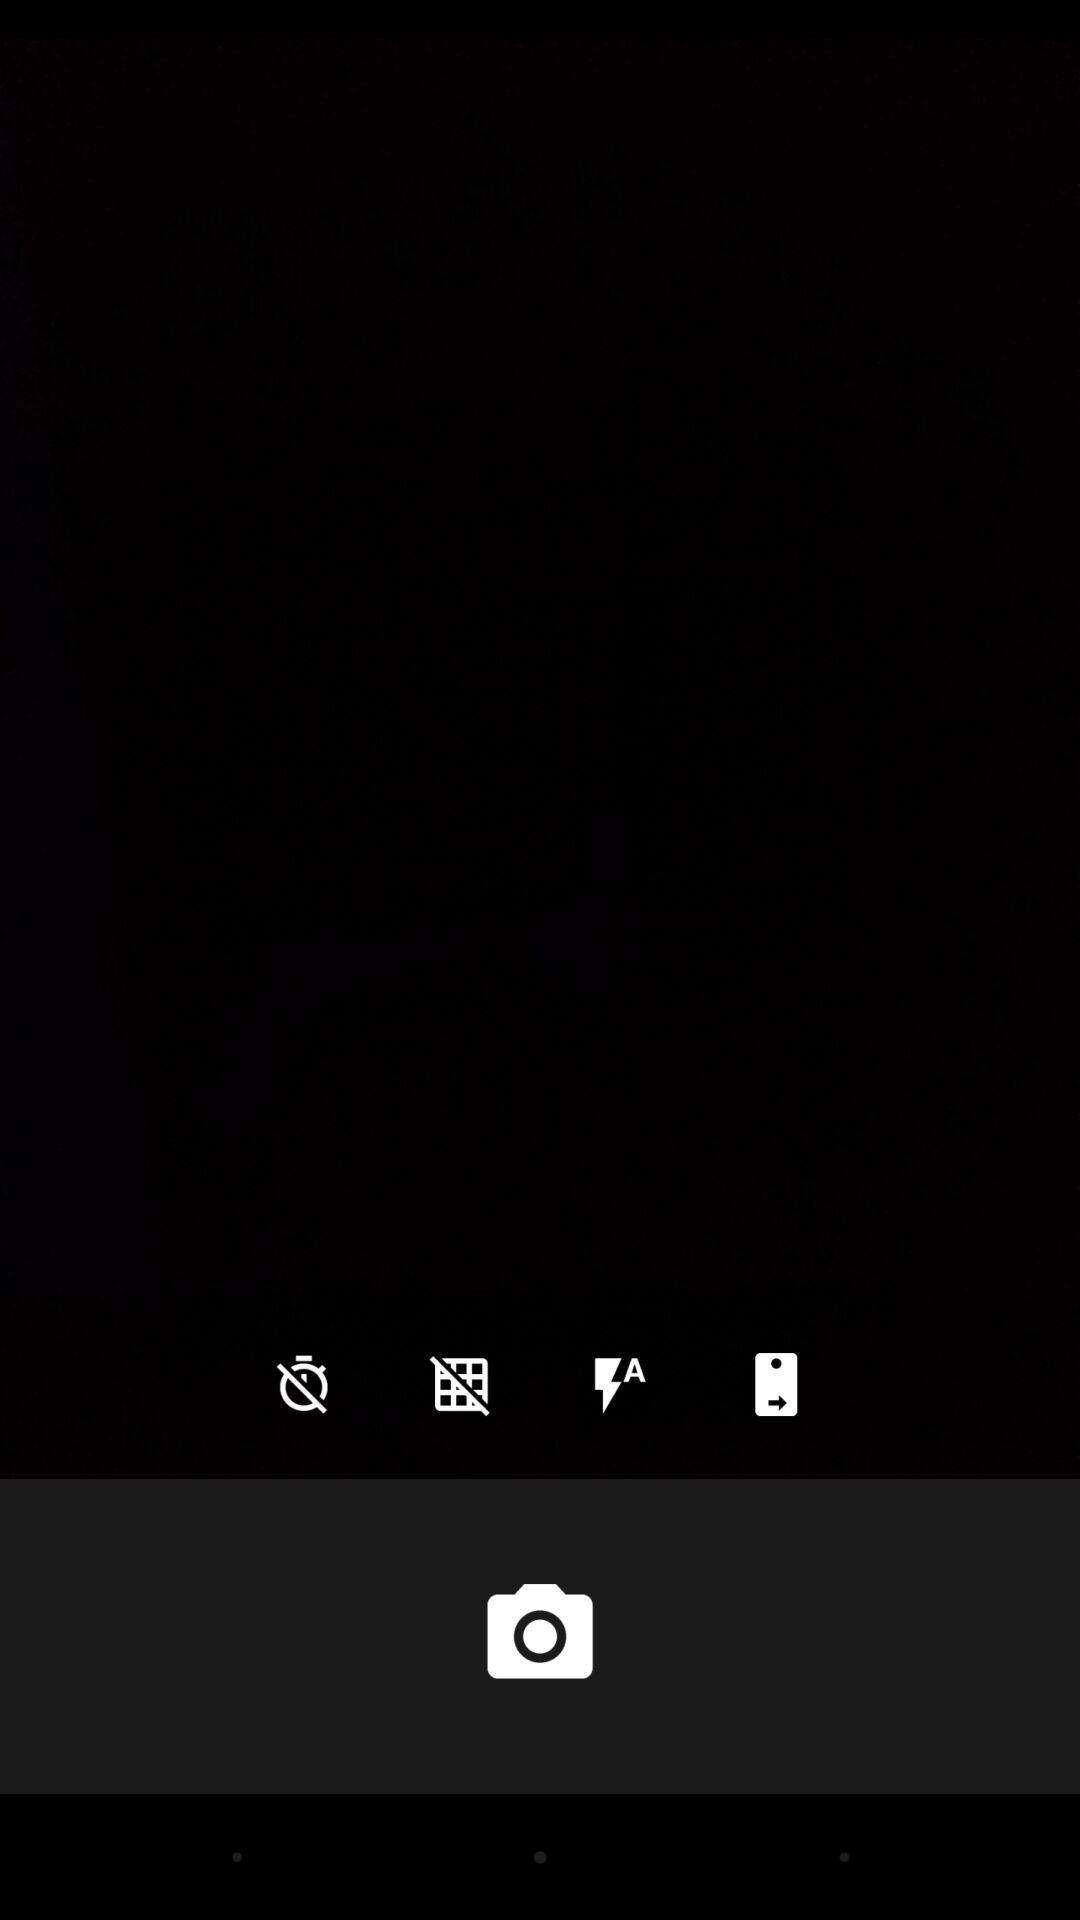Provide a description of this screenshot. Screen of a mobile camera. 